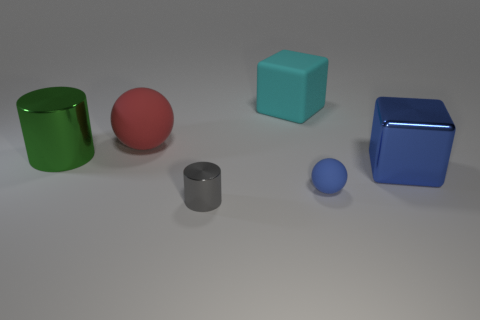Add 2 brown metal things. How many objects exist? 8 Subtract all cubes. How many objects are left? 4 Subtract 0 gray blocks. How many objects are left? 6 Subtract all tiny cyan rubber cylinders. Subtract all large red objects. How many objects are left? 5 Add 6 shiny things. How many shiny things are left? 9 Add 1 large cyan matte cylinders. How many large cyan matte cylinders exist? 1 